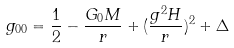<formula> <loc_0><loc_0><loc_500><loc_500>g _ { 0 0 } = \frac { 1 } { 2 } - \frac { G _ { 0 } M } { r } + ( \frac { g ^ { 2 } H } { r } ) ^ { 2 } + \Delta</formula> 